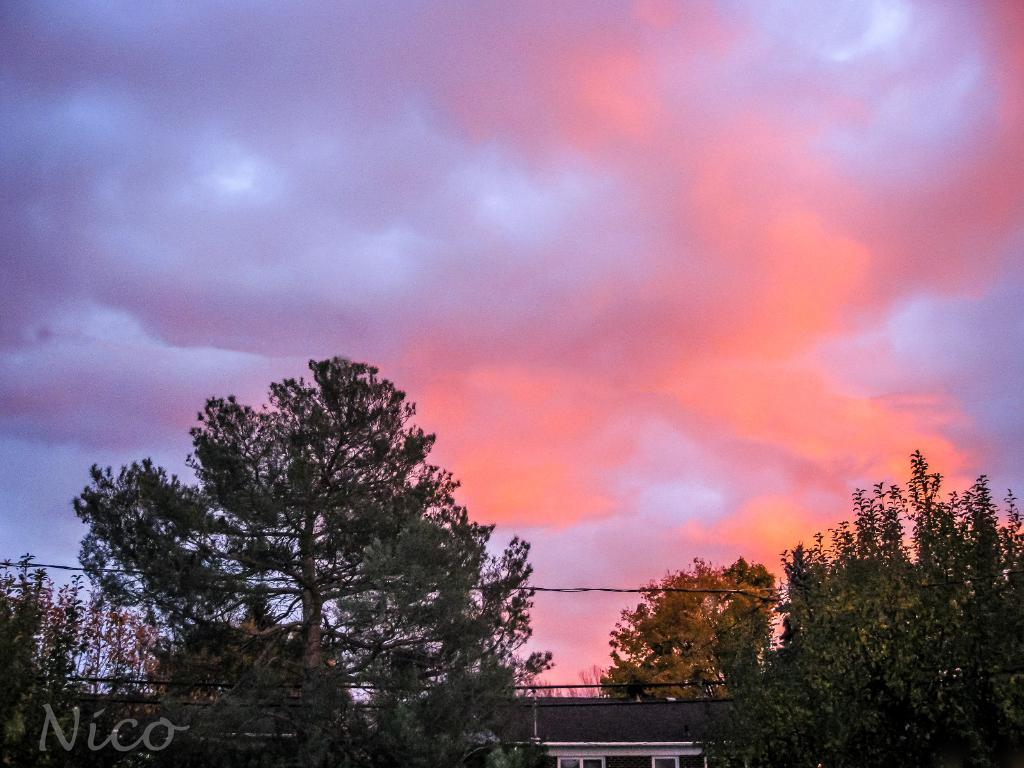What can be seen in the foreground of the image? In the foreground of the image, there are shops, wires, a board, and trees. What is visible in the background of the image? The sky is visible in the background of the image. Can you describe the time of day the image may have been taken? The image may have been taken in the evening, as suggested by the provided facts. What type of crime is being committed in the image? There is no indication of any crime being committed in the image. Can you tell me how many giraffes are present in the image? There are no giraffes present in the image. 